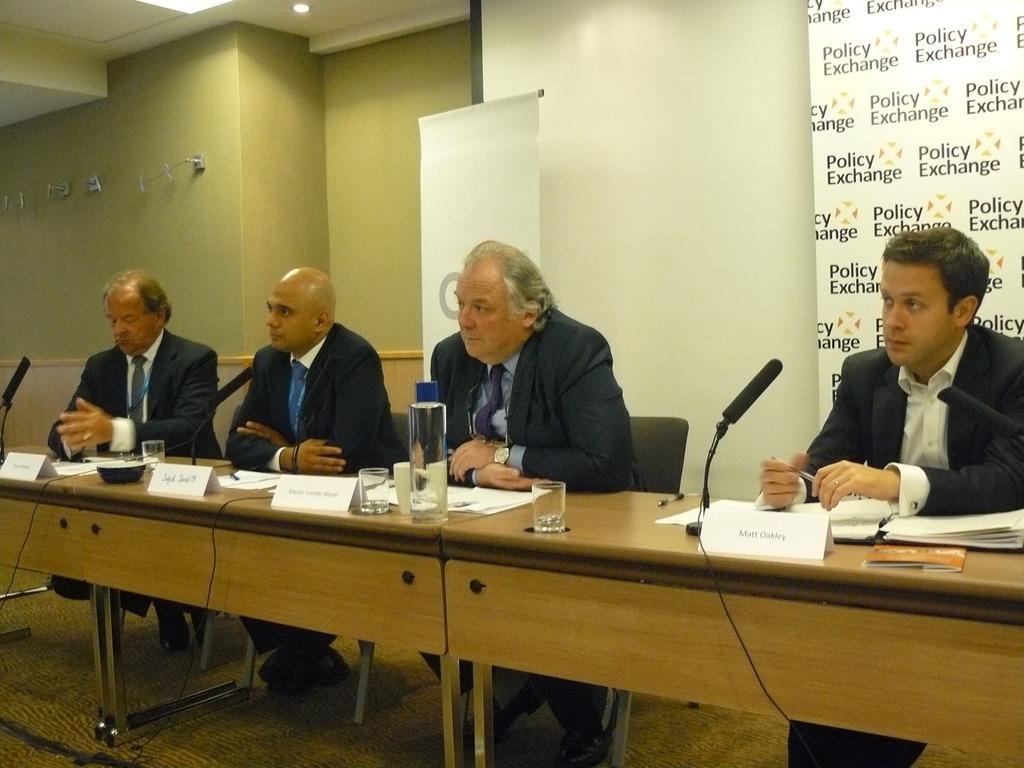Could you give a brief overview of what you see in this image? This image consists of four men sitting in the chairs. All are wearing black color suits. In front of them, there is a table made up of wood on which there are name plates, glasses, mics, and papers. In the background, there is a wall along with banners. At the bottom, there is a floor. 